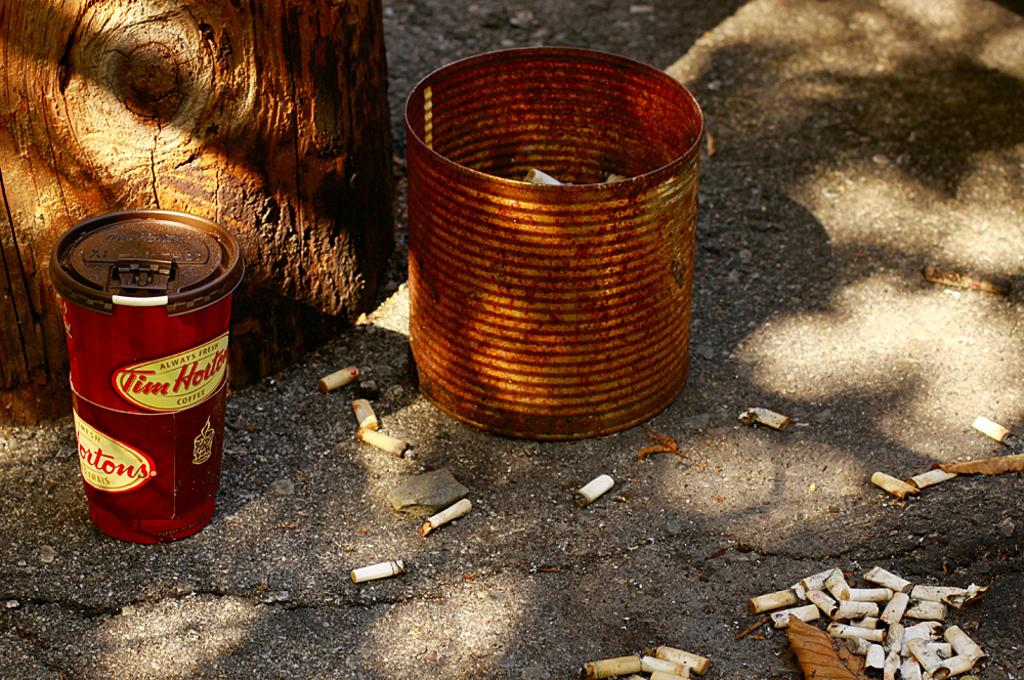<image>
Provide a brief description of the given image. A Tim Holter coffee cup stands on the sidewalk next to a rusty bin and cigarette butts. 